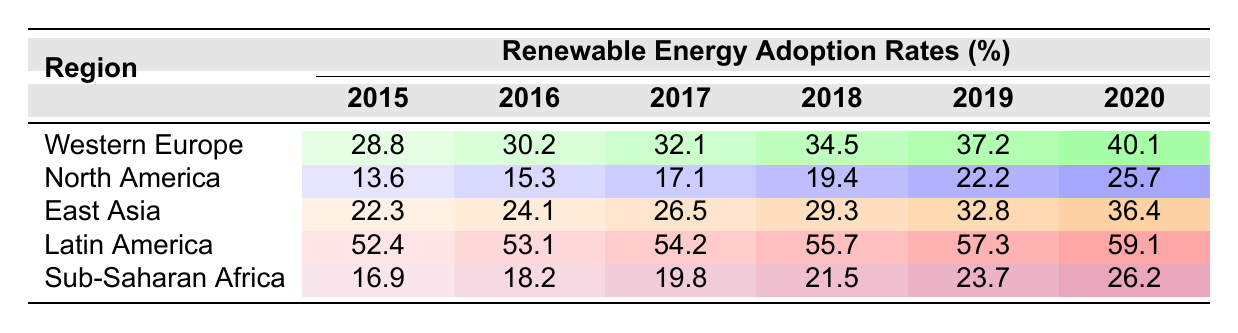What was the renewable energy adoption rate in Western Europe in 2019? Referring to the table, the renewable energy adoption rate for Western Europe in 2019 is listed as 37.2%.
Answer: 37.2% Which region had the highest renewable energy adoption rate in 2020? The table shows Latin America with a renewable energy adoption rate of 59.1% in 2020, which is higher than all other regions.
Answer: Latin America What was the difference in renewable energy adoption rates between North America and Sub-Saharan Africa in 2018? In 2018, North America had an adoption rate of 19.4% and Sub-Saharan Africa had 21.5%. The difference is 21.5% - 19.4% = 2.1%.
Answer: 2.1% What was the average renewable energy adoption rate for East Asia from 2015 to 2020? Adding up the values from 2015 (22.3), 2016 (24.1), 2017 (26.5), 2018 (29.3), 2019 (32.8), and 2020 (36.4) gives a total of 169.4. Dividing by 6 (the number of data points) gives an average of 28.23%.
Answer: 28.23% Which region showed the highest year-over-year growth in renewable energy adoption from 2015 to 2020? Reviewing the rates for each region from 2015 to 2020, we see regions grow as follows: Western Europe (11.3), North America (12.1), East Asia (14.1), Latin America (6.7), and Sub-Saharan Africa (9.3). East Asia has the highest growth of 14.1%.
Answer: East Asia Was the renewable energy adoption rate in 2016 higher in Latin America than in Western Europe? In 2016, Latin America had an adoption rate of 53.1% while Western Europe had 30.2%. Since 53.1% is greater than 30.2%, the statement is true.
Answer: Yes What renewable energy adoption rate did North America achieve in 2017? According to the table, North America's renewable energy adoption rate in 2017 is listed as 17.1%.
Answer: 17.1% If we compare the renewable energy adoption rate in Sub-Saharan Africa in 2020 to the rate in East Asia in the same year, which was higher? For 2020, Sub-Saharan Africa had a rate of 26.2% and East Asia had 36.4%. Since 36.4% is higher than 26.2%, East Asia's rate is higher.
Answer: East Asia What was the increase in renewable energy adoption rates in Western Europe from 2015 to 2018? The rate in 2015 for Western Europe was 28.8% and in 2018 it was 34.5%. The increase is 34.5% - 28.8% = 5.7%.
Answer: 5.7% In which year did Sub-Saharan Africa first exceed a 20% renewable energy adoption rate? By reviewing the data, Sub-Saharan Africa exceeded 20% for the first time in 2018 when the rate was 21.5%.
Answer: 2018 What was the overall trend in renewable energy adoption rates across all regions from 2015 to 2020? Observing the table, all regions show an increase in renewable energy adoption rates from 2015 to 2020, indicating an overall trend of growth in adoption.
Answer: Growth 